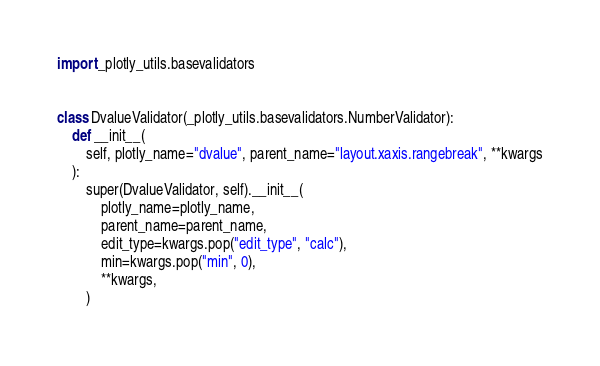Convert code to text. <code><loc_0><loc_0><loc_500><loc_500><_Python_>import _plotly_utils.basevalidators


class DvalueValidator(_plotly_utils.basevalidators.NumberValidator):
    def __init__(
        self, plotly_name="dvalue", parent_name="layout.xaxis.rangebreak", **kwargs
    ):
        super(DvalueValidator, self).__init__(
            plotly_name=plotly_name,
            parent_name=parent_name,
            edit_type=kwargs.pop("edit_type", "calc"),
            min=kwargs.pop("min", 0),
            **kwargs,
        )
</code> 